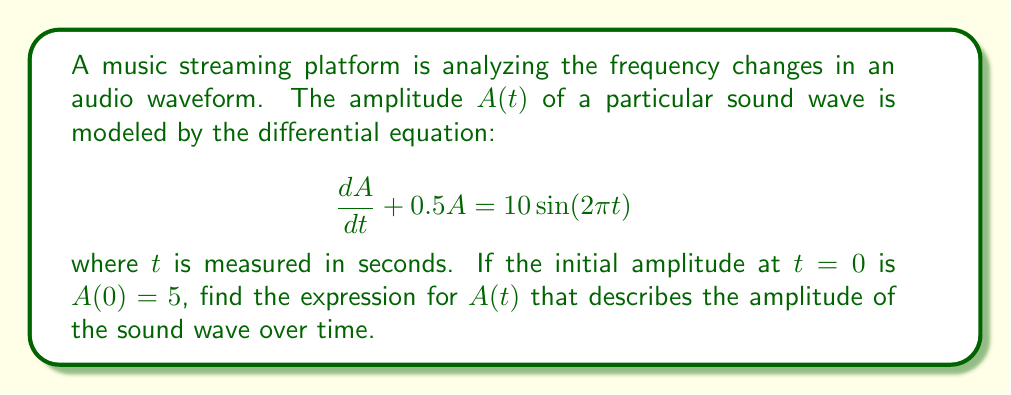Give your solution to this math problem. To solve this first-order linear differential equation, we'll use the integrating factor method:

1) The equation is in the form $\frac{dA}{dt} + P(t)A = Q(t)$, where $P(t) = 0.5$ and $Q(t) = 10\sin(2\pi t)$.

2) The integrating factor is $\mu(t) = e^{\int P(t) dt} = e^{\int 0.5 dt} = e^{0.5t}$.

3) Multiply both sides of the equation by $\mu(t)$:

   $e^{0.5t}\frac{dA}{dt} + 0.5e^{0.5t}A = 10e^{0.5t}\sin(2\pi t)$

4) The left side is now the derivative of $e^{0.5t}A$:

   $\frac{d}{dt}(e^{0.5t}A) = 10e^{0.5t}\sin(2\pi t)$

5) Integrate both sides:

   $e^{0.5t}A = \int 10e^{0.5t}\sin(2\pi t)dt$

6) To integrate the right side, use integration by parts twice:

   $\int e^{0.5t}\sin(2\pi t)dt = \frac{e^{0.5t}}{0.5^2 + (2\pi)^2}[0.5\sin(2\pi t) - 2\pi\cos(2\pi t)] + C$

7) Therefore:

   $e^{0.5t}A = \frac{10e^{0.5t}}{0.5^2 + (2\pi)^2}[0.5\sin(2\pi t) - 2\pi\cos(2\pi t)] + C$

8) Divide both sides by $e^{0.5t}$:

   $A = \frac{10}{0.5^2 + (2\pi)^2}[0.5\sin(2\pi t) - 2\pi\cos(2\pi t)] + Ce^{-0.5t}$

9) Use the initial condition $A(0) = 5$ to find $C$:

   $5 = \frac{10}{0.5^2 + (2\pi)^2}[-2\pi] + C$

   $C = 5 + \frac{20\pi}{0.5^2 + (2\pi)^2}$

10) Substitute this value of $C$ back into the general solution:

    $A(t) = \frac{10}{0.5^2 + (2\pi)^2}[0.5\sin(2\pi t) - 2\pi\cos(2\pi t)] + (5 + \frac{20\pi}{0.5^2 + (2\pi)^2})e^{-0.5t}$
Answer: $A(t) = \frac{10}{0.5^2 + (2\pi)^2}[0.5\sin(2\pi t) - 2\pi\cos(2\pi t)] + (5 + \frac{20\pi}{0.5^2 + (2\pi)^2})e^{-0.5t}$ 